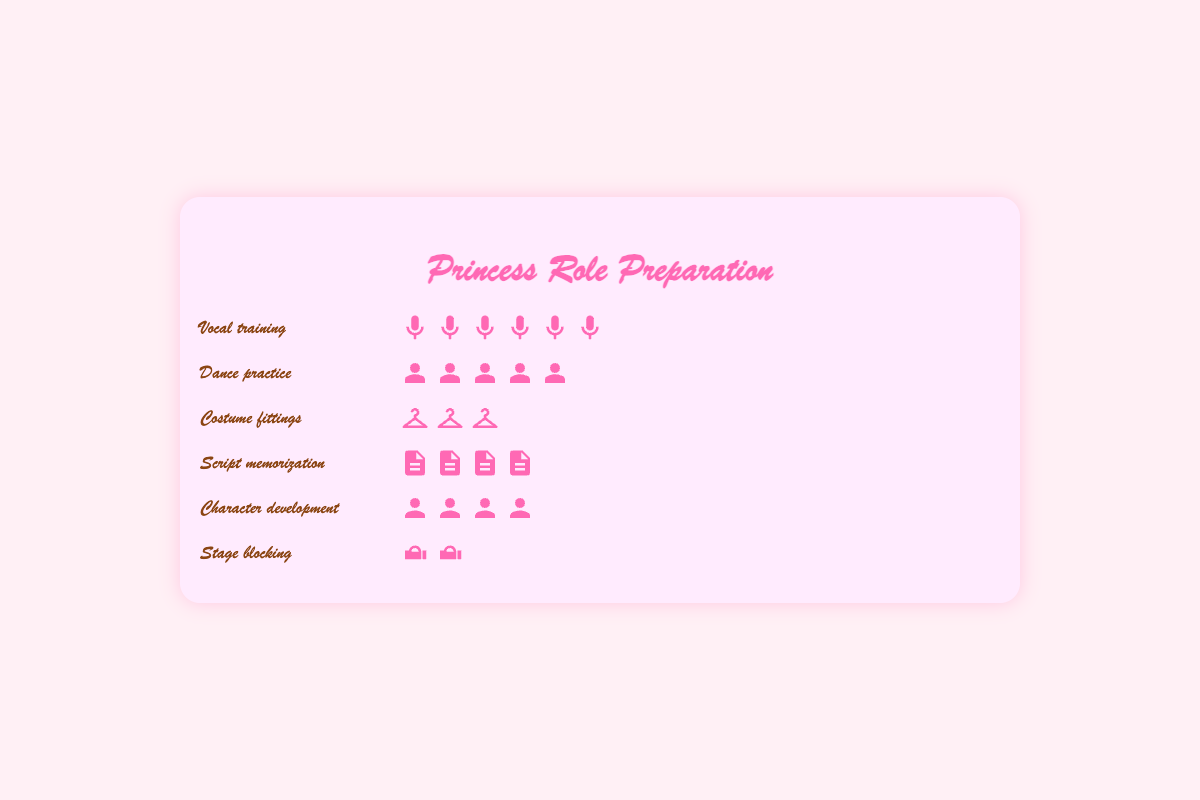Which aspect has the highest number of rehearsal hours? The aspect with the longest bar (icons) represents the highest number of rehearsal hours. The "Vocal training" aspect has the longest bar with many icons.
Answer: Vocal training How many more hours are spent on dance practice than stage blocking? Count the icons for both "Dance practice" and "Stage blocking". Dance practice has 5 icons (each representing 5 hours), while Stage blocking has 2 icons. So, the difference is (5 - 2) * 5 = 15 hours.
Answer: 15 hours What is the total number of hours spent on costume fittings and script memorization combined? Add the hours represented by the icons for "Costume fittings" and "Script memorization". Costume fittings have 3 icons (15 hours) and Script memorization has 4 icons (20 hours). Total is 15 + 20 = 35 hours.
Answer: 35 hours Which preparation aspect has the fewest rehearsal hours? The aspect with the shortest bar (least number of icons) represents the fewest rehearsal hours. "Stage blocking" has the shortest bar with just 2 icons.
Answer: Stage blocking How does the number of hours spent on character development compare to the hours spent on script memorization? Count the icons for both "Character development" and "Script memorization". Character development has 4 icons (20 hours) and Script memorization also has 4 icons (20 hours). They are equal.
Answer: Equal What is the total number of hours spent on all preparation aspects combined? Sum all the hours represented by the icons of each aspect. Vocal training (30), Dance practice (25), Costume fittings (15), Script memorization (20), Character development (18), Stage blocking (12). Total = 30 + 25 + 15 + 20 + 18 + 12 = 120 hours.
Answer: 120 hours Is more time spent on character development or dance practice? Count the icons for both "Character development" and "Dance practice". Character development has 4 icons (20 hours), and Dance practice has 5 icons (25 hours). Dance practice has more hours.
Answer: Dance practice What are the two aspects with the closest number of rehearsal hours? Compare the bar lengths (number of icons) for all aspects to find the two with the least difference. "Character development" (18 hours) and "Script memorization" (20 hours) are the closest.
Answer: Character development and Script memorization 